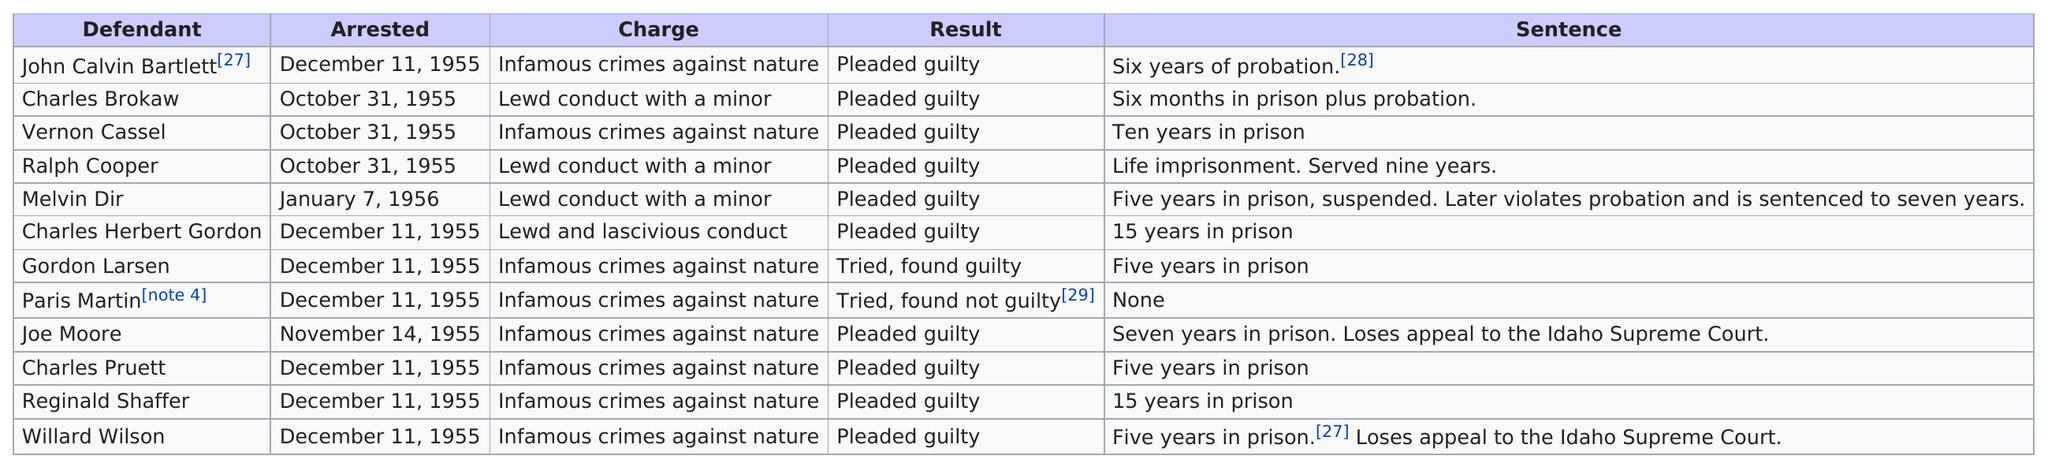Draw attention to some important aspects in this diagram. Melvin Dirst was arrested on January 7, 1956. In December of 1955, seven defendants were arrested. The defendant was charged with committing lewd conduct with a minor after their arrest in 1955. Vernon Cassel and Reginald Shaffer were sentenced to ten and 15 years in prison respectively. Nine defendants received at least five years in prison. 